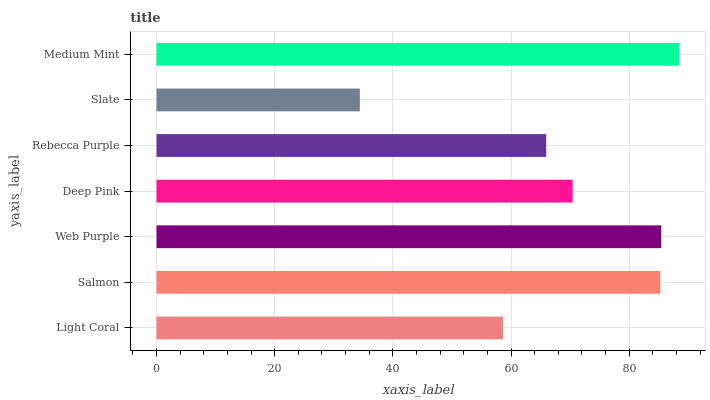Is Slate the minimum?
Answer yes or no. Yes. Is Medium Mint the maximum?
Answer yes or no. Yes. Is Salmon the minimum?
Answer yes or no. No. Is Salmon the maximum?
Answer yes or no. No. Is Salmon greater than Light Coral?
Answer yes or no. Yes. Is Light Coral less than Salmon?
Answer yes or no. Yes. Is Light Coral greater than Salmon?
Answer yes or no. No. Is Salmon less than Light Coral?
Answer yes or no. No. Is Deep Pink the high median?
Answer yes or no. Yes. Is Deep Pink the low median?
Answer yes or no. Yes. Is Light Coral the high median?
Answer yes or no. No. Is Medium Mint the low median?
Answer yes or no. No. 